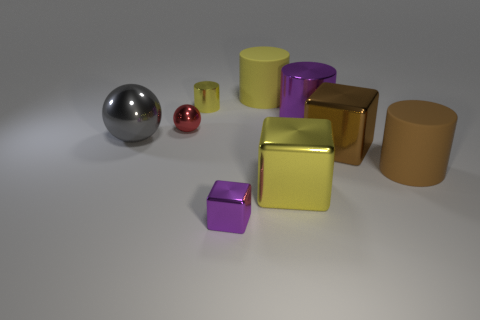What number of gray things are big matte balls or small cylinders?
Offer a very short reply. 0. Are there fewer tiny red spheres that are in front of the red metallic thing than red objects that are left of the large brown metallic thing?
Offer a very short reply. Yes. Are there any matte cylinders of the same size as the red metal sphere?
Provide a succinct answer. No. There is a matte cylinder that is on the right side of the yellow rubber cylinder; is its size the same as the tiny red thing?
Provide a short and direct response. No. Is the number of small brown rubber cubes greater than the number of big matte objects?
Provide a short and direct response. No. Is there a tiny brown matte thing that has the same shape as the gray thing?
Your response must be concise. No. There is a large metallic thing left of the red metallic object; what shape is it?
Your answer should be very brief. Sphere. How many red spheres are behind the yellow shiny thing in front of the small object that is to the left of the small yellow metal object?
Offer a terse response. 1. There is a large metal block on the right side of the big purple metal cylinder; is its color the same as the tiny metallic sphere?
Provide a short and direct response. No. What number of other objects are the same shape as the big purple thing?
Your answer should be compact. 3. 